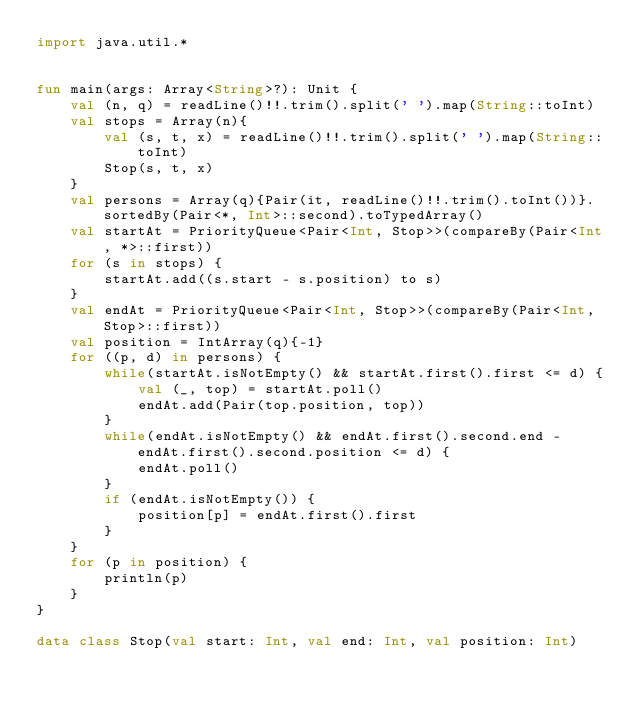<code> <loc_0><loc_0><loc_500><loc_500><_Kotlin_>import java.util.*


fun main(args: Array<String>?): Unit {
    val (n, q) = readLine()!!.trim().split(' ').map(String::toInt)
    val stops = Array(n){
        val (s, t, x) = readLine()!!.trim().split(' ').map(String::toInt)
        Stop(s, t, x)
    }
    val persons = Array(q){Pair(it, readLine()!!.trim().toInt())}.sortedBy(Pair<*, Int>::second).toTypedArray()
    val startAt = PriorityQueue<Pair<Int, Stop>>(compareBy(Pair<Int, *>::first))
    for (s in stops) {
        startAt.add((s.start - s.position) to s)
    }
    val endAt = PriorityQueue<Pair<Int, Stop>>(compareBy(Pair<Int, Stop>::first))
    val position = IntArray(q){-1}
    for ((p, d) in persons) {
        while(startAt.isNotEmpty() && startAt.first().first <= d) {
            val (_, top) = startAt.poll()
            endAt.add(Pair(top.position, top))
        }
        while(endAt.isNotEmpty() && endAt.first().second.end - endAt.first().second.position <= d) {
            endAt.poll()
        }
        if (endAt.isNotEmpty()) {
            position[p] = endAt.first().first
        }
    }
    for (p in position) {
        println(p)
    }
}

data class Stop(val start: Int, val end: Int, val position: Int)
</code> 